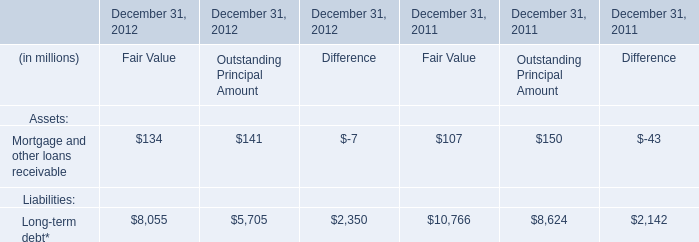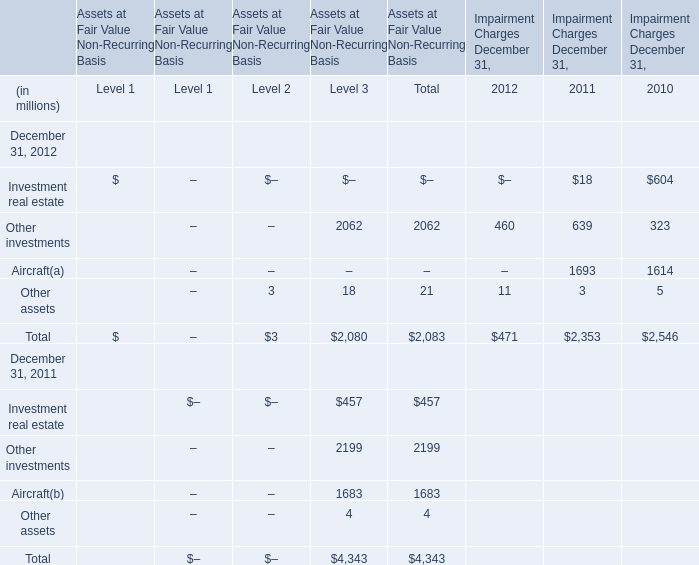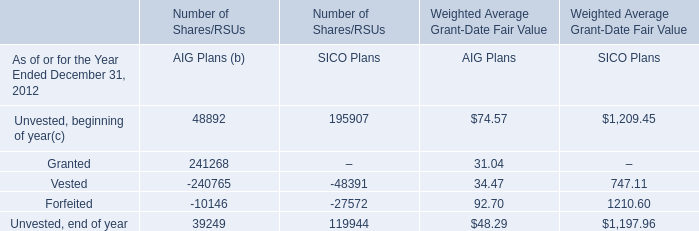How many elements are greater than 1000 in 2011? 
Answer: 2. 